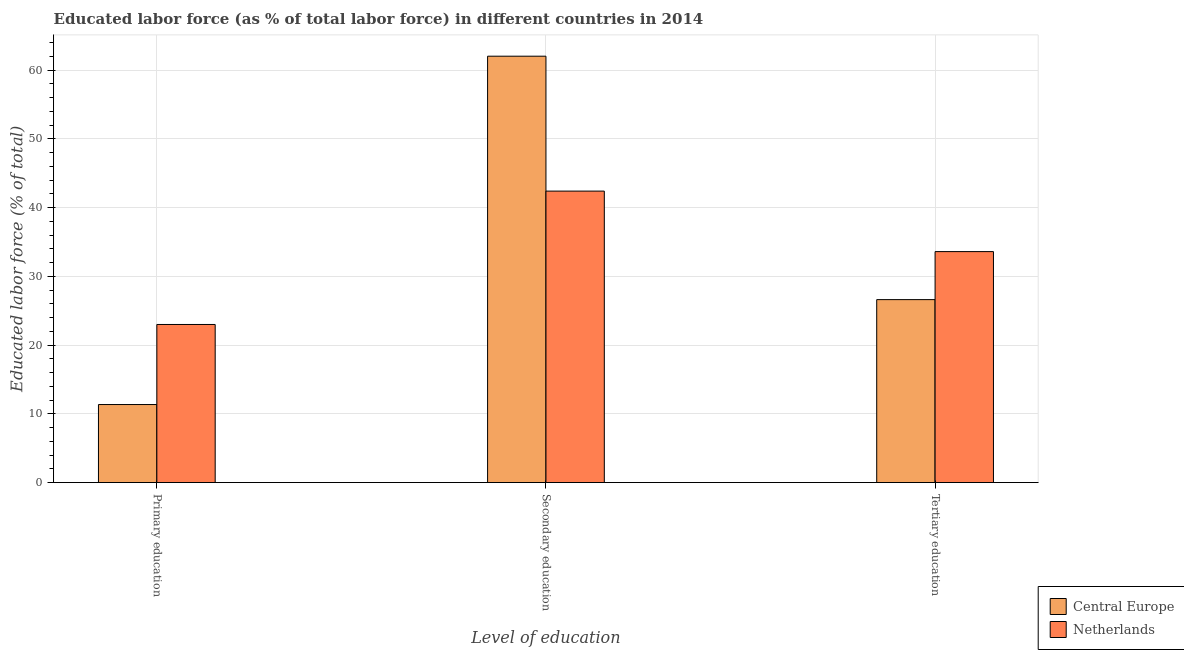Are the number of bars per tick equal to the number of legend labels?
Keep it short and to the point. Yes. How many bars are there on the 2nd tick from the left?
Give a very brief answer. 2. How many bars are there on the 2nd tick from the right?
Your response must be concise. 2. What is the label of the 3rd group of bars from the left?
Offer a very short reply. Tertiary education. What is the percentage of labor force who received tertiary education in Central Europe?
Give a very brief answer. 26.62. Across all countries, what is the maximum percentage of labor force who received tertiary education?
Your answer should be compact. 33.6. Across all countries, what is the minimum percentage of labor force who received secondary education?
Provide a short and direct response. 42.4. What is the total percentage of labor force who received primary education in the graph?
Your response must be concise. 34.35. What is the difference between the percentage of labor force who received tertiary education in Netherlands and that in Central Europe?
Your response must be concise. 6.98. What is the difference between the percentage of labor force who received primary education in Netherlands and the percentage of labor force who received tertiary education in Central Europe?
Keep it short and to the point. -3.62. What is the average percentage of labor force who received tertiary education per country?
Keep it short and to the point. 30.11. What is the difference between the percentage of labor force who received secondary education and percentage of labor force who received tertiary education in Central Europe?
Make the answer very short. 35.41. In how many countries, is the percentage of labor force who received tertiary education greater than 38 %?
Your answer should be very brief. 0. What is the ratio of the percentage of labor force who received primary education in Central Europe to that in Netherlands?
Offer a terse response. 0.49. Is the percentage of labor force who received secondary education in Central Europe less than that in Netherlands?
Give a very brief answer. No. What is the difference between the highest and the second highest percentage of labor force who received tertiary education?
Make the answer very short. 6.98. What is the difference between the highest and the lowest percentage of labor force who received primary education?
Your answer should be compact. 11.65. Is the sum of the percentage of labor force who received tertiary education in Central Europe and Netherlands greater than the maximum percentage of labor force who received primary education across all countries?
Your answer should be compact. Yes. Is it the case that in every country, the sum of the percentage of labor force who received primary education and percentage of labor force who received secondary education is greater than the percentage of labor force who received tertiary education?
Make the answer very short. Yes. How many bars are there?
Provide a succinct answer. 6. How many countries are there in the graph?
Your answer should be compact. 2. Does the graph contain any zero values?
Your answer should be compact. No. How many legend labels are there?
Your answer should be very brief. 2. What is the title of the graph?
Your answer should be compact. Educated labor force (as % of total labor force) in different countries in 2014. Does "Sub-Saharan Africa (all income levels)" appear as one of the legend labels in the graph?
Keep it short and to the point. No. What is the label or title of the X-axis?
Make the answer very short. Level of education. What is the label or title of the Y-axis?
Your answer should be compact. Educated labor force (% of total). What is the Educated labor force (% of total) in Central Europe in Primary education?
Provide a succinct answer. 11.35. What is the Educated labor force (% of total) of Central Europe in Secondary education?
Provide a succinct answer. 62.02. What is the Educated labor force (% of total) in Netherlands in Secondary education?
Give a very brief answer. 42.4. What is the Educated labor force (% of total) of Central Europe in Tertiary education?
Keep it short and to the point. 26.62. What is the Educated labor force (% of total) of Netherlands in Tertiary education?
Give a very brief answer. 33.6. Across all Level of education, what is the maximum Educated labor force (% of total) of Central Europe?
Your answer should be compact. 62.02. Across all Level of education, what is the maximum Educated labor force (% of total) in Netherlands?
Ensure brevity in your answer.  42.4. Across all Level of education, what is the minimum Educated labor force (% of total) of Central Europe?
Offer a terse response. 11.35. What is the total Educated labor force (% of total) of Central Europe in the graph?
Offer a terse response. 99.99. What is the difference between the Educated labor force (% of total) in Central Europe in Primary education and that in Secondary education?
Give a very brief answer. -50.67. What is the difference between the Educated labor force (% of total) of Netherlands in Primary education and that in Secondary education?
Your answer should be very brief. -19.4. What is the difference between the Educated labor force (% of total) in Central Europe in Primary education and that in Tertiary education?
Your response must be concise. -15.26. What is the difference between the Educated labor force (% of total) of Netherlands in Primary education and that in Tertiary education?
Your answer should be compact. -10.6. What is the difference between the Educated labor force (% of total) of Central Europe in Secondary education and that in Tertiary education?
Offer a terse response. 35.41. What is the difference between the Educated labor force (% of total) in Central Europe in Primary education and the Educated labor force (% of total) in Netherlands in Secondary education?
Keep it short and to the point. -31.05. What is the difference between the Educated labor force (% of total) of Central Europe in Primary education and the Educated labor force (% of total) of Netherlands in Tertiary education?
Provide a short and direct response. -22.25. What is the difference between the Educated labor force (% of total) of Central Europe in Secondary education and the Educated labor force (% of total) of Netherlands in Tertiary education?
Offer a very short reply. 28.42. What is the average Educated labor force (% of total) in Central Europe per Level of education?
Offer a very short reply. 33.33. What is the difference between the Educated labor force (% of total) in Central Europe and Educated labor force (% of total) in Netherlands in Primary education?
Your answer should be very brief. -11.65. What is the difference between the Educated labor force (% of total) in Central Europe and Educated labor force (% of total) in Netherlands in Secondary education?
Make the answer very short. 19.62. What is the difference between the Educated labor force (% of total) of Central Europe and Educated labor force (% of total) of Netherlands in Tertiary education?
Your answer should be compact. -6.98. What is the ratio of the Educated labor force (% of total) in Central Europe in Primary education to that in Secondary education?
Keep it short and to the point. 0.18. What is the ratio of the Educated labor force (% of total) of Netherlands in Primary education to that in Secondary education?
Give a very brief answer. 0.54. What is the ratio of the Educated labor force (% of total) of Central Europe in Primary education to that in Tertiary education?
Keep it short and to the point. 0.43. What is the ratio of the Educated labor force (% of total) of Netherlands in Primary education to that in Tertiary education?
Provide a succinct answer. 0.68. What is the ratio of the Educated labor force (% of total) of Central Europe in Secondary education to that in Tertiary education?
Give a very brief answer. 2.33. What is the ratio of the Educated labor force (% of total) in Netherlands in Secondary education to that in Tertiary education?
Ensure brevity in your answer.  1.26. What is the difference between the highest and the second highest Educated labor force (% of total) in Central Europe?
Keep it short and to the point. 35.41. What is the difference between the highest and the second highest Educated labor force (% of total) in Netherlands?
Give a very brief answer. 8.8. What is the difference between the highest and the lowest Educated labor force (% of total) in Central Europe?
Provide a short and direct response. 50.67. What is the difference between the highest and the lowest Educated labor force (% of total) in Netherlands?
Keep it short and to the point. 19.4. 